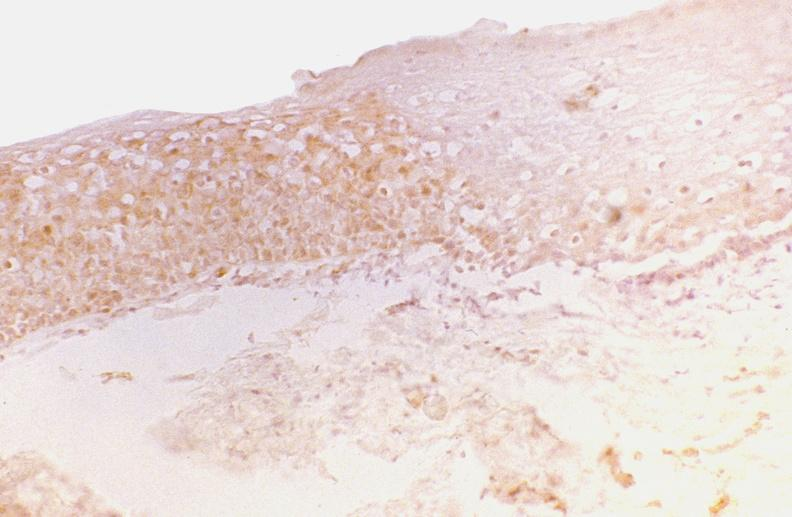does this image show oral dysplasia, tgf-gamma?
Answer the question using a single word or phrase. Yes 